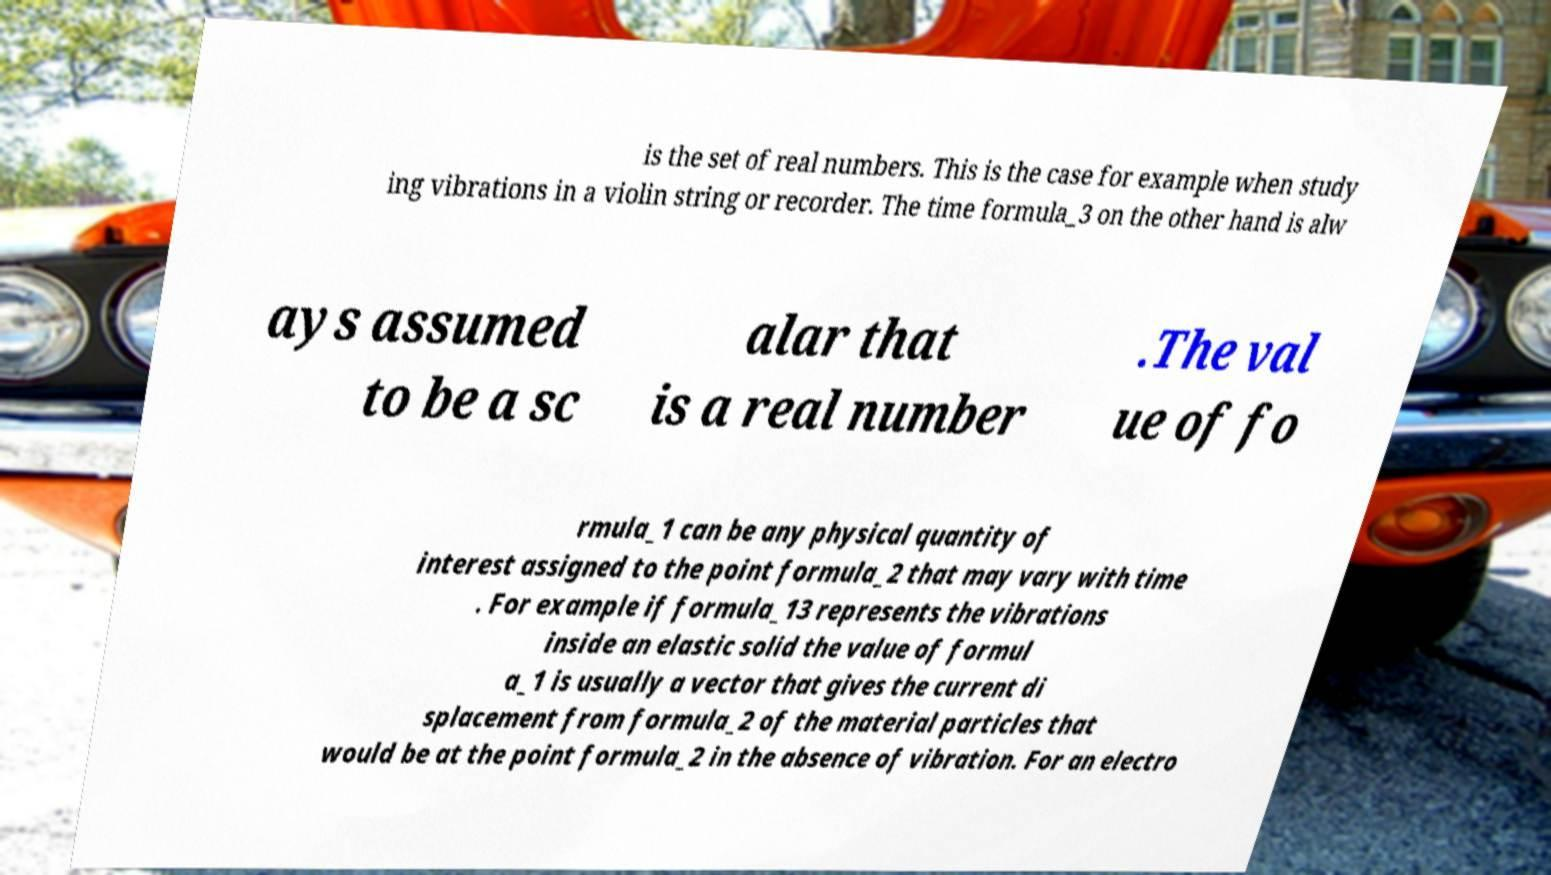Please identify and transcribe the text found in this image. is the set of real numbers. This is the case for example when study ing vibrations in a violin string or recorder. The time formula_3 on the other hand is alw ays assumed to be a sc alar that is a real number .The val ue of fo rmula_1 can be any physical quantity of interest assigned to the point formula_2 that may vary with time . For example if formula_13 represents the vibrations inside an elastic solid the value of formul a_1 is usually a vector that gives the current di splacement from formula_2 of the material particles that would be at the point formula_2 in the absence of vibration. For an electro 